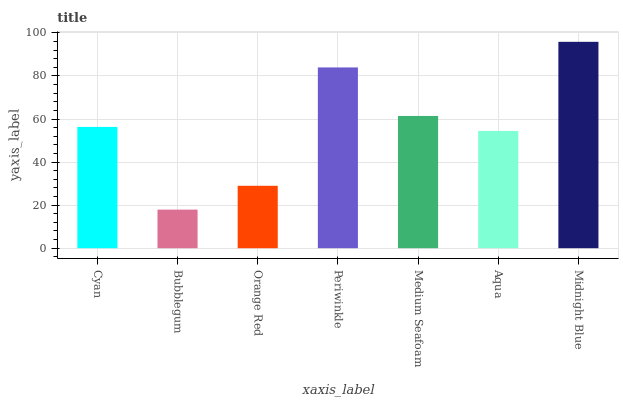Is Orange Red the minimum?
Answer yes or no. No. Is Orange Red the maximum?
Answer yes or no. No. Is Orange Red greater than Bubblegum?
Answer yes or no. Yes. Is Bubblegum less than Orange Red?
Answer yes or no. Yes. Is Bubblegum greater than Orange Red?
Answer yes or no. No. Is Orange Red less than Bubblegum?
Answer yes or no. No. Is Cyan the high median?
Answer yes or no. Yes. Is Cyan the low median?
Answer yes or no. Yes. Is Midnight Blue the high median?
Answer yes or no. No. Is Midnight Blue the low median?
Answer yes or no. No. 